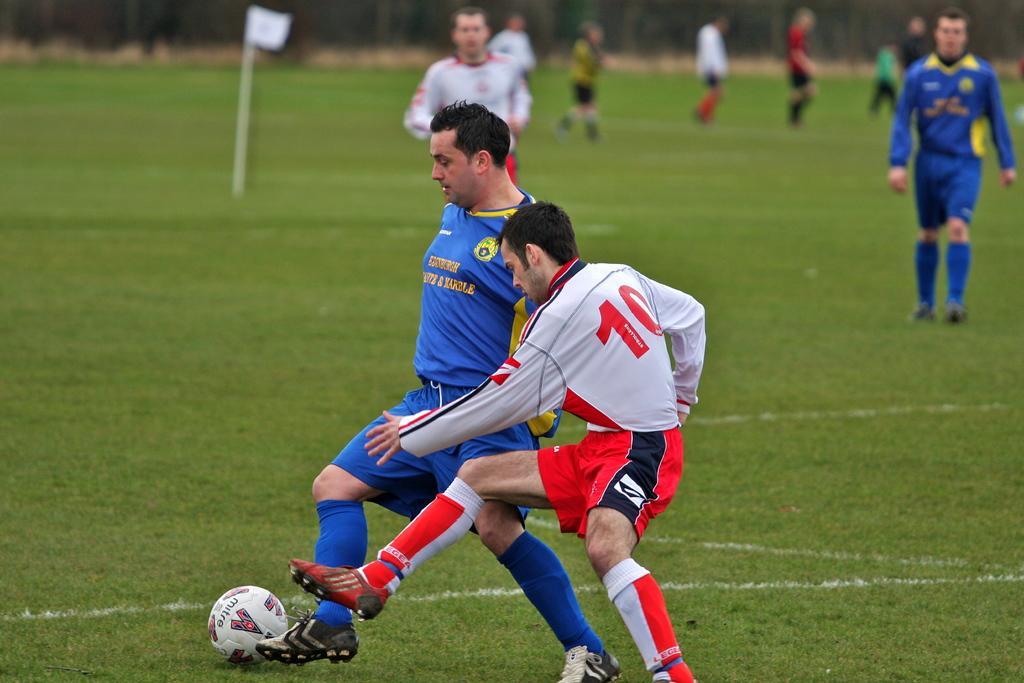How would you summarize this image in a sentence or two? In this image I can see a ground in the ground I can see there are two persons playing a game and they are going to kick the ball with their legs and the ball visible on the ground ,at the top I can see few persons , in the middle I can see two persons 